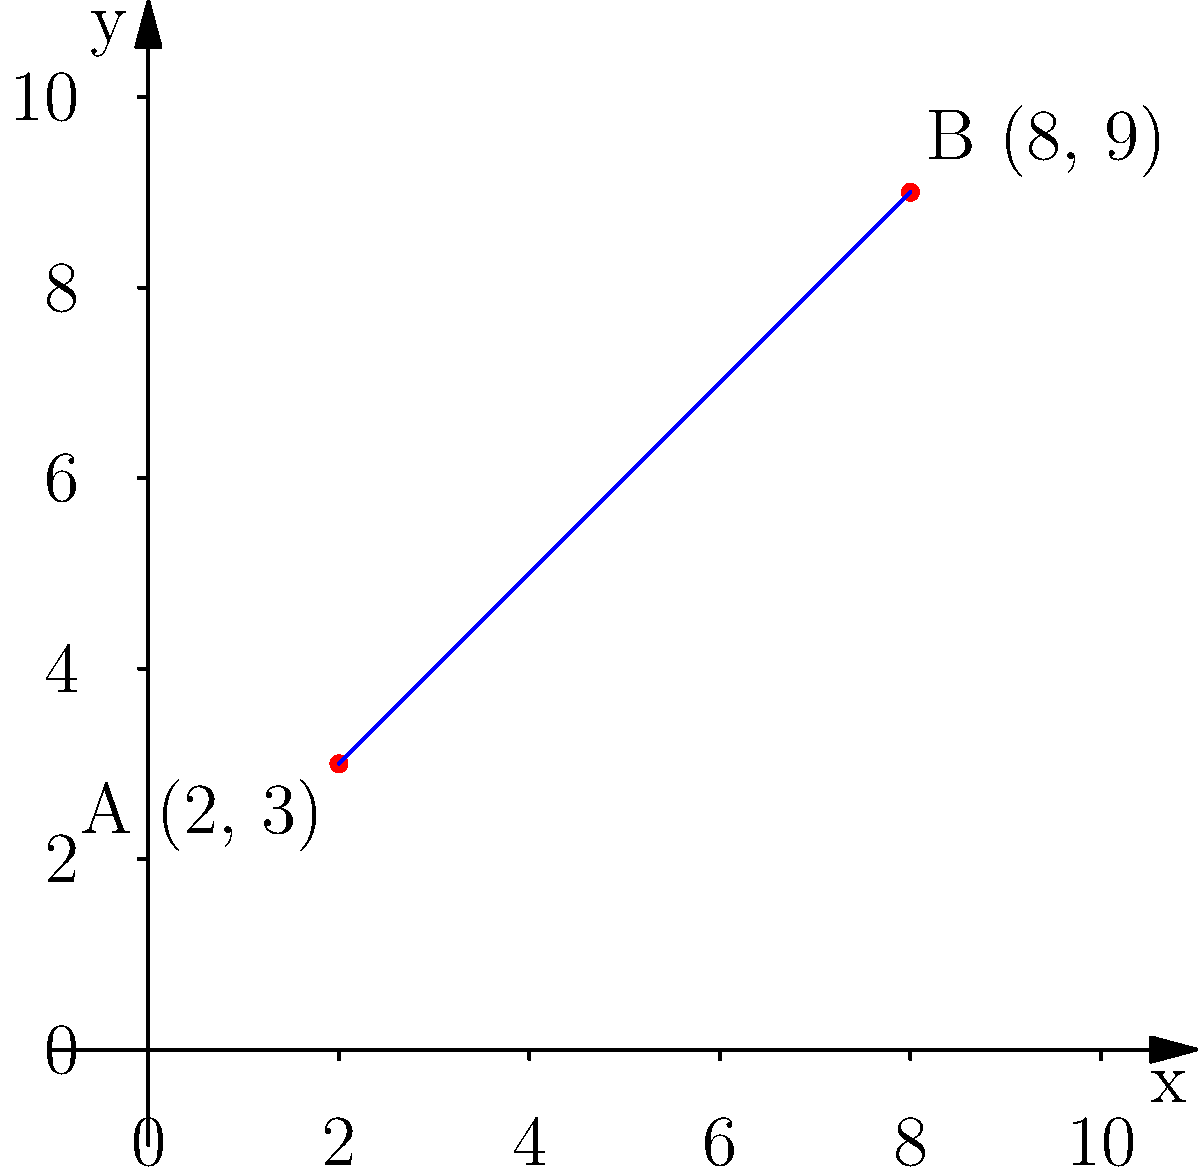In a heritage conservation area, two historical landmarks are located at points A(2, 3) and B(8, 9) on a coordinate grid. Calculate the slope of the line connecting these two points of interest. How would this slope affect the preservation planning for the area between these landmarks? To find the slope of the line connecting points A(2, 3) and B(8, 9), we'll use the slope formula:

$$ \text{slope} = m = \frac{y_2 - y_1}{x_2 - x_1} $$

Where $(x_1, y_1)$ is the first point and $(x_2, y_2)$ is the second point.

Step 1: Identify the coordinates
- Point A: $(x_1, y_1) = (2, 3)$
- Point B: $(x_2, y_2) = (8, 9)$

Step 2: Plug the values into the slope formula
$$ m = \frac{9 - 3}{8 - 2} = \frac{6}{6} $$

Step 3: Simplify the fraction
$$ m = 1 $$

The slope of the line connecting the two historical landmarks is 1.

Interpretation for preservation planning:
A slope of 1 indicates a moderate, consistent incline between the two points. This information is crucial for preservation planning as it affects:

1. Accessibility: The gradual slope might require considerations for wheelchair access and pedestrian pathways.
2. Water drainage: The slope will influence how water flows between the landmarks, which is important for preventing erosion and protecting foundations.
3. Visual impact: The line of sight between the landmarks is unobstructed, which may be important for maintaining historical viewsheds.
4. Construction considerations: Any new structures or restoration work between these points would need to account for this slope to maintain the area's historical character.

Understanding this slope helps in making informed decisions about conservation efforts, ensuring that any interventions or preservation work aligns with the natural topography of the heritage area.
Answer: Slope = 1; affects accessibility, drainage, viewsheds, and construction in preservation planning. 